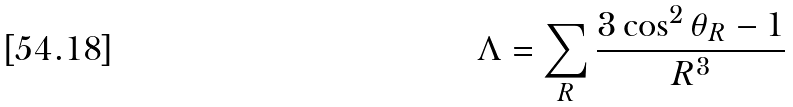Convert formula to latex. <formula><loc_0><loc_0><loc_500><loc_500>\Lambda = \sum _ { R } \frac { 3 \cos ^ { 2 } \theta _ { R } - 1 } { R ^ { 3 } }</formula> 